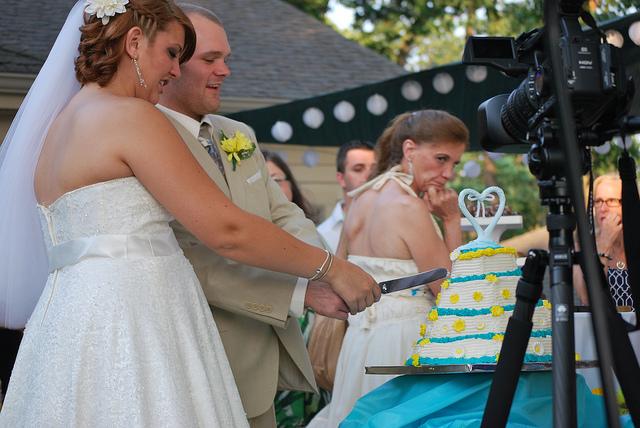Is this a wedding?
Answer briefly. Yes. How many tiers is the cake?
Answer briefly. 4. What are the people cutting?
Write a very short answer. Cake. 